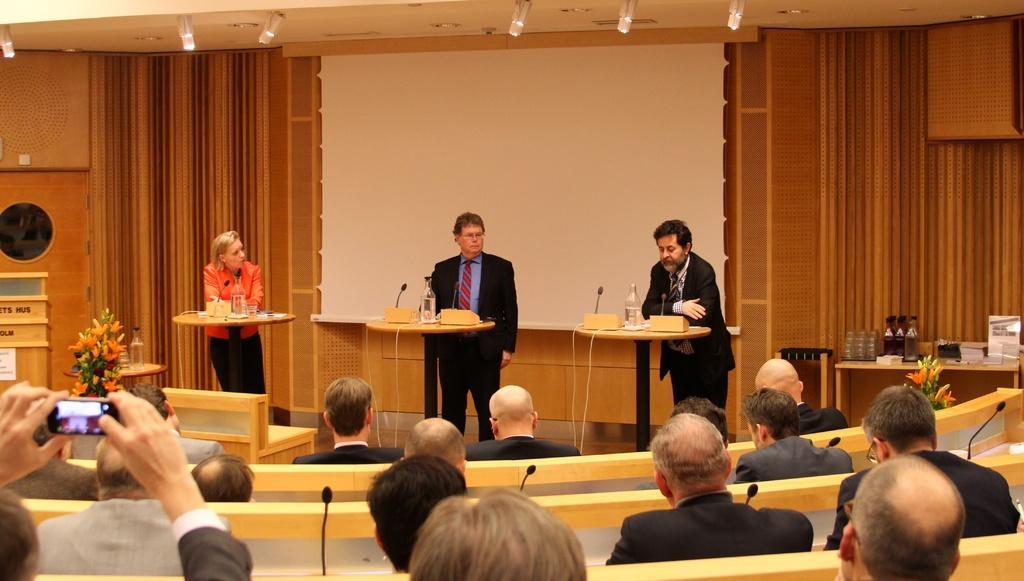Describe this image in one or two sentences. In the center of the image we can see three people standing. There are podiums placed before them. There are bottles and mics placed on the podiums. At the bottom there are people sitting. The man sitting on the left is holding a mobile in his hand. In the background there is a bouquet and curtains. At the top there are lights. In the center there is a screen. 